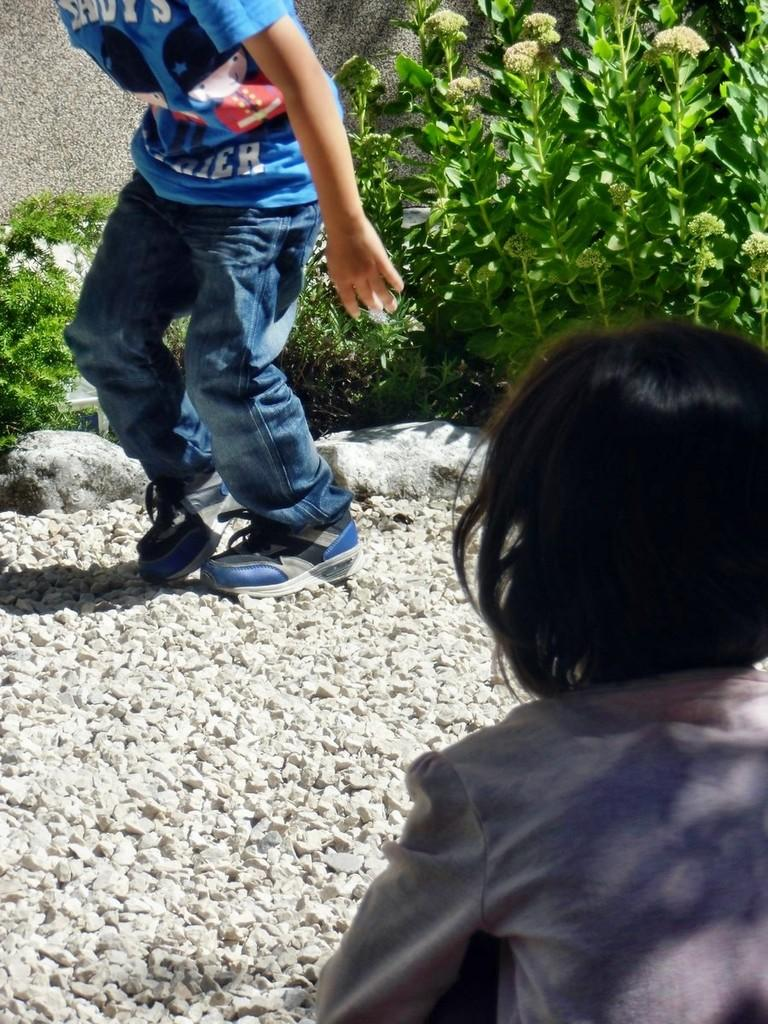How many kids are in the image? There are two kids in the image. What can be found on the ground in the image? There are stones on the ground in the image. What type of vegetation is present in the image? There are plants in the image. What type of yak can be seen walking among the plants in the image? There is no yak present in the image; it features two kids and plants. Can you tell me the name of the writer who created the image? The image is a photograph or illustration, not a written work, so there is no writer associated with it. 